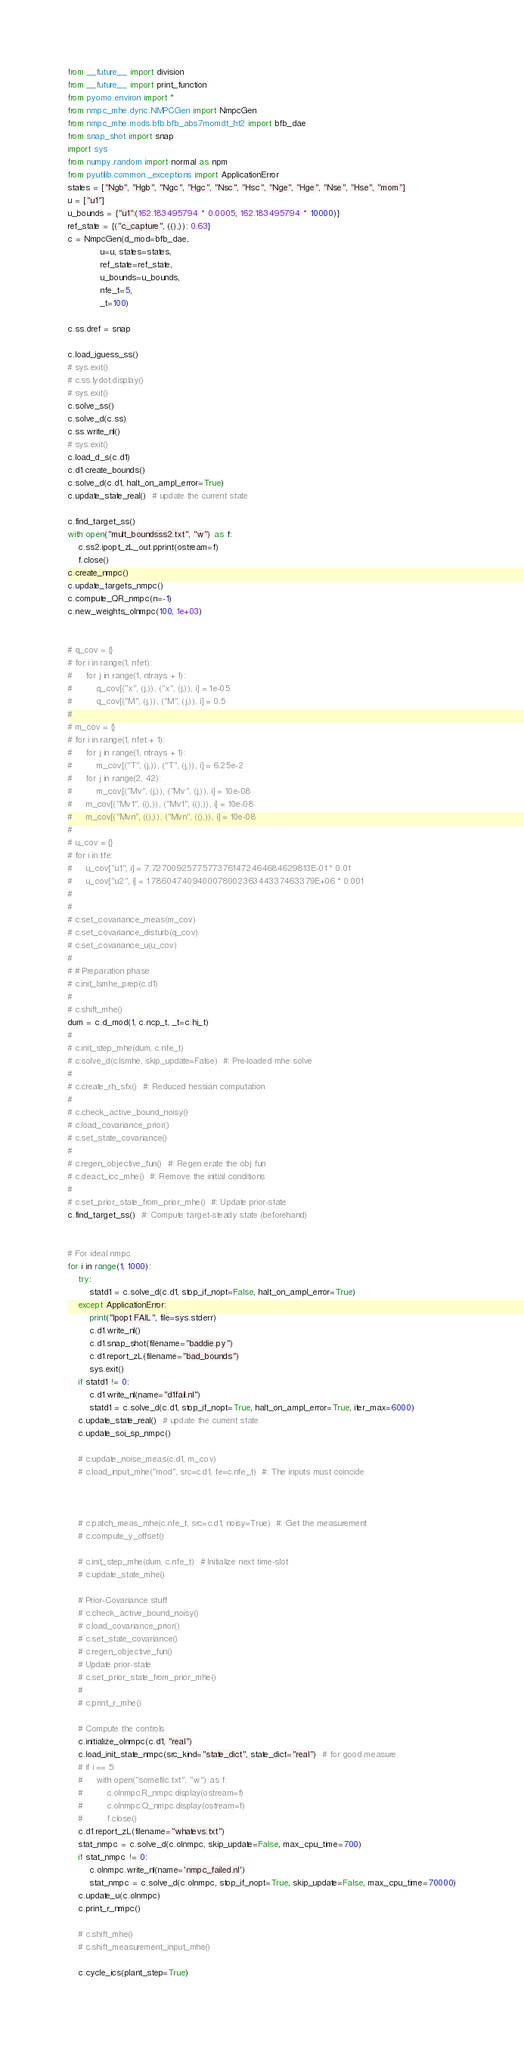<code> <loc_0><loc_0><loc_500><loc_500><_Python_>from __future__ import division
from __future__ import print_function
from pyomo.environ import *
from nmpc_mhe.dync.NMPCGen import NmpcGen
from nmpc_mhe.mods.bfb.bfb_abs7momdt_ht2 import bfb_dae
from snap_shot import snap
import sys
from numpy.random import normal as npm
from pyutilib.common._exceptions import ApplicationError
states = ["Ngb", "Hgb", "Ngc", "Hgc", "Nsc", "Hsc", "Nge", "Hge", "Nse", "Hse", "mom"]
u = ["u1"]
u_bounds = {"u1":(162.183495794 * 0.0005, 162.183495794 * 10000)}
ref_state = {("c_capture", ((),)): 0.63}
c = NmpcGen(d_mod=bfb_dae,
            u=u, states=states,
            ref_state=ref_state,
            u_bounds=u_bounds,
            nfe_t=5,
            _t=100)

c.ss.dref = snap

c.load_iguess_ss()
# sys.exit()
# c.ss.lydot.display()
# sys.exit()
c.solve_ss()
c.solve_d(c.ss)
c.ss.write_nl()
# sys.exit()
c.load_d_s(c.d1)
c.d1.create_bounds()
c.solve_d(c.d1, halt_on_ampl_error=True)
c.update_state_real()  # update the current state

c.find_target_ss()
with open("mult_boundsss2.txt", "w") as f:
    c.ss2.ipopt_zL_out.pprint(ostream=f)
    f.close()
c.create_nmpc()
c.update_targets_nmpc()
c.compute_QR_nmpc(n=-1)
c.new_weights_olnmpc(100, 1e+03)


# q_cov = {}
# for i in range(1, nfet):
#     for j in range(1, ntrays + 1):
#         q_cov[("x", (j,)), ("x", (j,)), i] = 1e-05
#         q_cov[("M", (j,)), ("M", (j,)), i] = 0.5
#
# m_cov = {}
# for i in range(1, nfet + 1):
#     for j in range(1, ntrays + 1):
#         m_cov[("T", (j,)), ("T", (j,)), i] = 6.25e-2
#     for j in range(2, 42):
#         m_cov[("Mv", (j,)), ("Mv", (j,)), i] = 10e-08
#     m_cov[("Mv1", ((),)), ("Mv1", ((),)), i] = 10e-08
#     m_cov[("Mvn", ((),)), ("Mvn", ((),)), i] = 10e-08
#
# u_cov = {}
# for i in tfe:
#     u_cov["u1", i] = 7.72700925775773761472464684629813E-01 * 0.01
#     u_cov["u2", i] = 1.78604740940007800236344337463379E+06 * 0.001
#
#
# c.set_covariance_meas(m_cov)
# c.set_covariance_disturb(q_cov)
# c.set_covariance_u(u_cov)
#
# # Preparation phase
# c.init_lsmhe_prep(c.d1)
#
# c.shift_mhe()
dum = c.d_mod(1, c.ncp_t, _t=c.hi_t)
#
# c.init_step_mhe(dum, c.nfe_t)
# c.solve_d(c.lsmhe, skip_update=False)  #: Pre-loaded mhe solve
#
# c.create_rh_sfx()  #: Reduced hessian computation
#
# c.check_active_bound_noisy()
# c.load_covariance_prior()
# c.set_state_covariance()
#
# c.regen_objective_fun()  #: Regen erate the obj fun
# c.deact_icc_mhe()  #: Remove the initial conditions
#
# c.set_prior_state_from_prior_mhe()  #: Update prior-state
c.find_target_ss()  #: Compute target-steady state (beforehand)


# For ideal nmpc
for i in range(1, 1000):
    try:
        statd1 = c.solve_d(c.d1, stop_if_nopt=False, halt_on_ampl_error=True)
    except ApplicationError:
        print("Ipopt FAIL", file=sys.stderr)
        c.d1.write_nl()
        c.d1.snap_shot(filename="baddie.py")
        c.d1.report_zL(filename="bad_bounds")
        sys.exit()
    if statd1 != 0:
        c.d1.write_nl(name="d1fail.nl")
        statd1 = c.solve_d(c.d1, stop_if_nopt=True, halt_on_ampl_error=True, iter_max=6000)
    c.update_state_real()  # update the current state
    c.update_soi_sp_nmpc()

    # c.update_noise_meas(c.d1, m_cov)
    # c.load_input_mhe("mod", src=c.d1, fe=c.nfe_t)  #: The inputs must coincide



    # c.patch_meas_mhe(c.nfe_t, src=c.d1, noisy=True)  #: Get the measurement
    # c.compute_y_offset()

    # c.init_step_mhe(dum, c.nfe_t)  # Initialize next time-slot
    # c.update_state_mhe()

    # Prior-Covariance stuff
    # c.check_active_bound_noisy()
    # c.load_covariance_prior()
    # c.set_state_covariance()
    # c.regen_objective_fun()
    # Update prior-state
    # c.set_prior_state_from_prior_mhe()
    #
    # c.print_r_mhe()

    # Compute the controls
    c.initialize_olnmpc(c.d1, "real")
    c.load_init_state_nmpc(src_kind="state_dict", state_dict="real")  # for good measure
    # if i == 5:
    #     with open("somefilc.txt", "w") as f:
    #         c.olnmpc.R_nmpc.display(ostream=f)
    #         c.olnmpc.Q_nmpc.display(ostream=f)
    #         f.close()
    c.d1.report_zL(filename="whatevs.txt")
    stat_nmpc = c.solve_d(c.olnmpc, skip_update=False, max_cpu_time=700)
    if stat_nmpc != 0:
        c.olnmpc.write_nl(name='nmpc_failed.nl')
        stat_nmpc = c.solve_d(c.olnmpc, stop_if_nopt=True, skip_update=False, max_cpu_time=70000)
    c.update_u(c.olnmpc)
    c.print_r_nmpc()

    # c.shift_mhe()
    # c.shift_measurement_input_mhe()

    c.cycle_ics(plant_step=True)</code> 